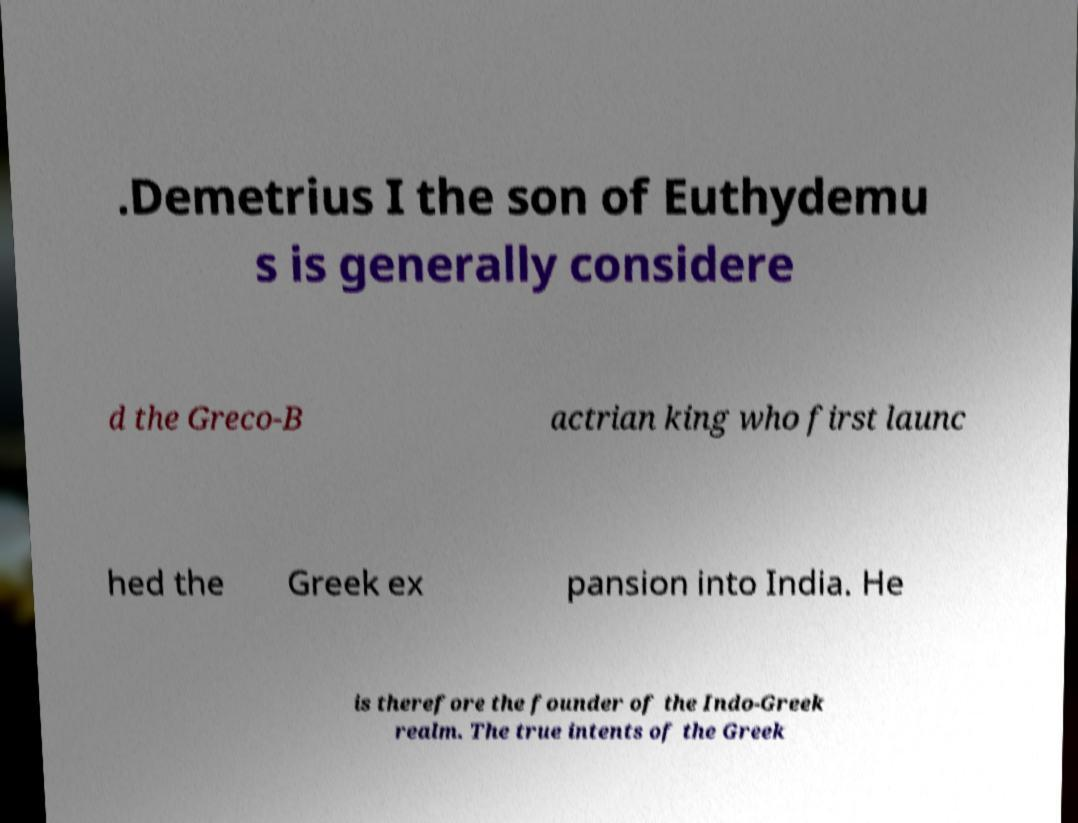Please read and relay the text visible in this image. What does it say? .Demetrius I the son of Euthydemu s is generally considere d the Greco-B actrian king who first launc hed the Greek ex pansion into India. He is therefore the founder of the Indo-Greek realm. The true intents of the Greek 